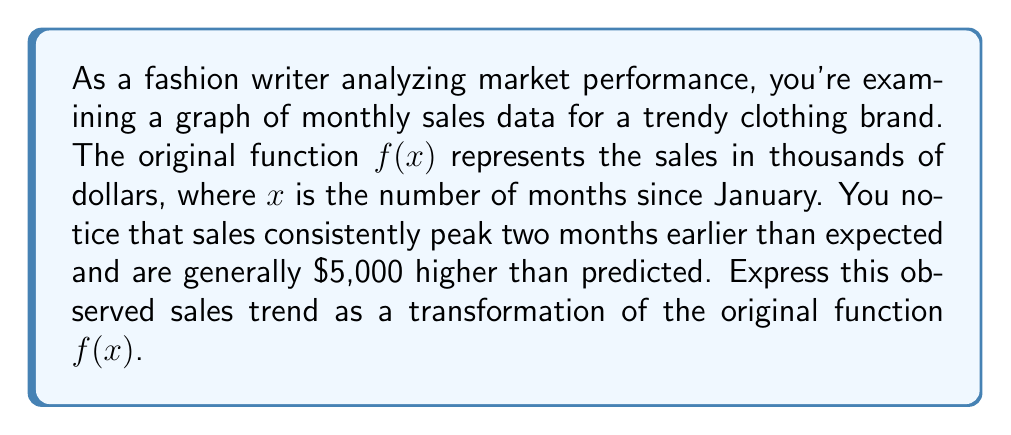Solve this math problem. To solve this problem, we need to apply two transformations to the original function $f(x)$:

1. Horizontal shift: The sales peak two months earlier than expected. This means we need to shift the graph 2 units to the right. The transformation for this is $x \rightarrow x - 2$.

2. Vertical shift: The sales are generally $5,000 higher than predicted. Since the function is in thousands of dollars, this translates to a vertical shift of 5 units up. The transformation for this is $y \rightarrow y + 5$.

Applying these transformations to the original function $f(x)$:

1. First, apply the horizontal shift: $f(x - 2)$
2. Then, apply the vertical shift: $f(x - 2) + 5$

Therefore, the new function representing the observed sales trend is $g(x) = f(x - 2) + 5$.

This transformation means that for any given month $x$, the observed sales $g(x)$ can be calculated by finding the original predicted sales for two months earlier $f(x - 2)$ and adding $5,000 to that value.
Answer: $g(x) = f(x - 2) + 5$ 